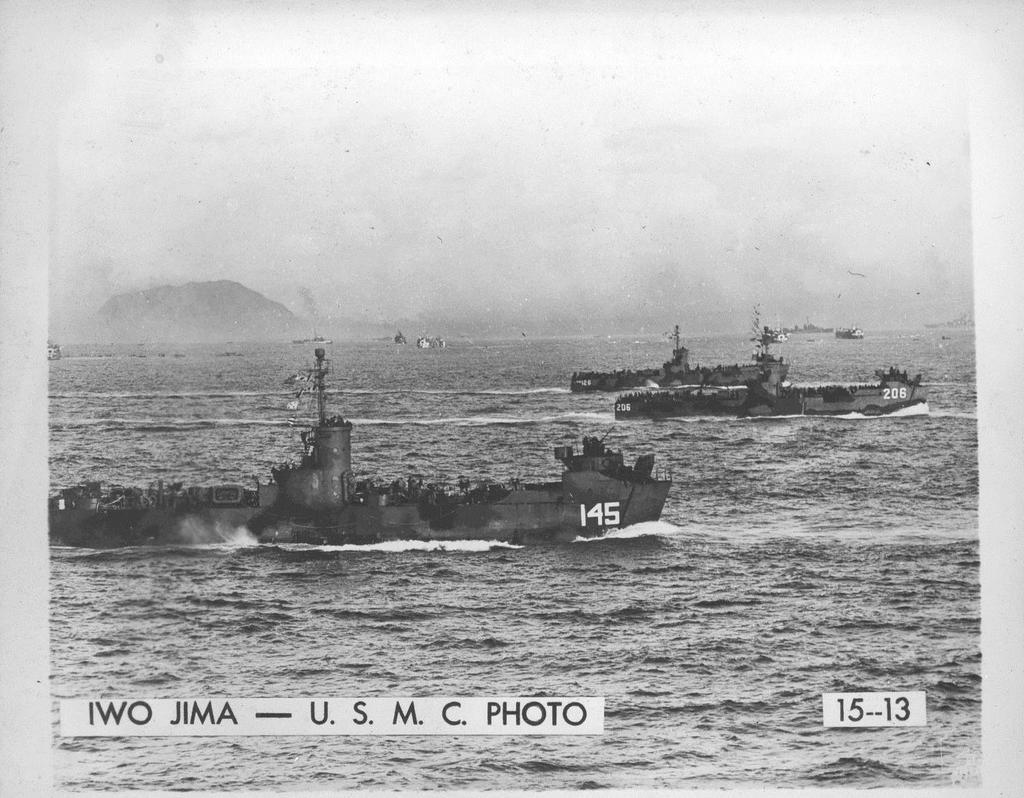<image>
Offer a succinct explanation of the picture presented. Army ships number 145 and 206 are near Iwo Jima. 